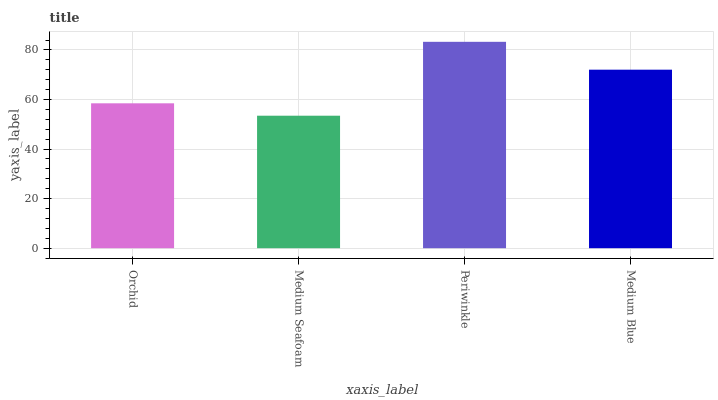Is Medium Seafoam the minimum?
Answer yes or no. Yes. Is Periwinkle the maximum?
Answer yes or no. Yes. Is Periwinkle the minimum?
Answer yes or no. No. Is Medium Seafoam the maximum?
Answer yes or no. No. Is Periwinkle greater than Medium Seafoam?
Answer yes or no. Yes. Is Medium Seafoam less than Periwinkle?
Answer yes or no. Yes. Is Medium Seafoam greater than Periwinkle?
Answer yes or no. No. Is Periwinkle less than Medium Seafoam?
Answer yes or no. No. Is Medium Blue the high median?
Answer yes or no. Yes. Is Orchid the low median?
Answer yes or no. Yes. Is Medium Seafoam the high median?
Answer yes or no. No. Is Periwinkle the low median?
Answer yes or no. No. 